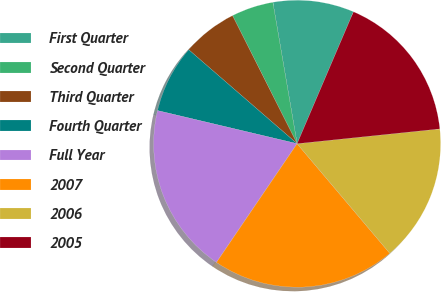Convert chart. <chart><loc_0><loc_0><loc_500><loc_500><pie_chart><fcel>First Quarter<fcel>Second Quarter<fcel>Third Quarter<fcel>Fourth Quarter<fcel>Full Year<fcel>2007<fcel>2006<fcel>2005<nl><fcel>9.13%<fcel>4.73%<fcel>6.2%<fcel>7.66%<fcel>19.21%<fcel>20.67%<fcel>15.47%<fcel>16.93%<nl></chart> 